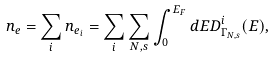<formula> <loc_0><loc_0><loc_500><loc_500>n _ { e } = \sum _ { i } n _ { e _ { i } } = \sum _ { i } \sum _ { N , s } \int _ { 0 } ^ { E _ { F } } d E D _ { \Gamma _ { N , s } } ^ { i } ( E ) ,</formula> 